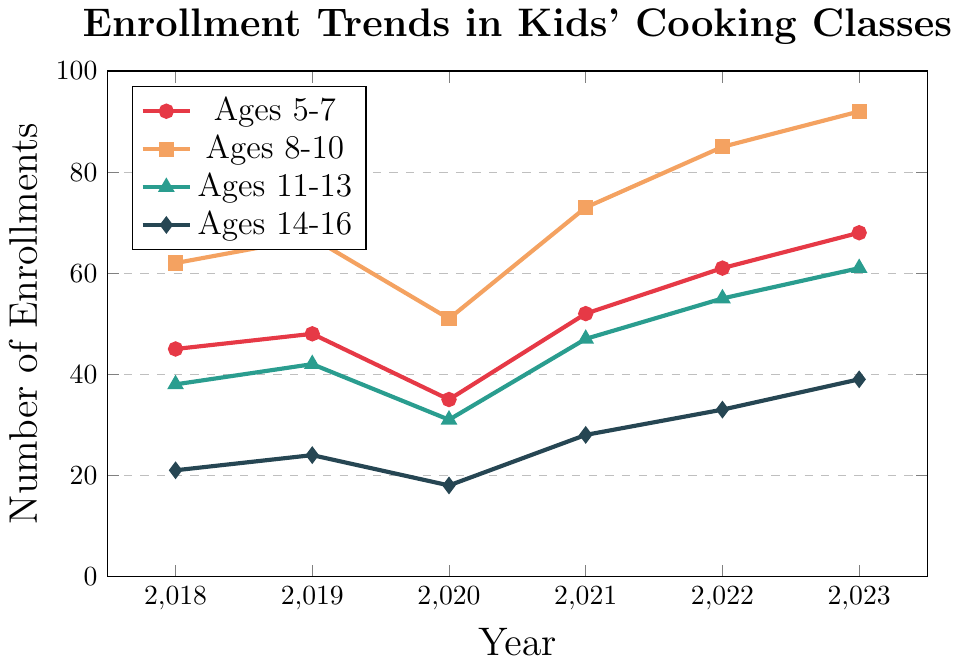What was the enrollment for Ages 8-10 in 2020? Looking at the plot, locate the line representing Ages 8-10, and find the data point corresponding to the year 2020.
Answer: 51 Which age group had the highest enrollment in 2023? Identify the highest point on the lines for the year 2023, which represents the enrollment for each age group. The line for Ages 8-10 (92) is the highest.
Answer: Ages 8-10 What is the total enrollment for all age groups in 2021? Sum the data points for all age groups. For 2021: Ages 5-7 (52) + Ages 8-10 (73) + Ages 11-13 (47) + Ages 14-16 (28). Total = 52 + 73 + 47 + 28 = 200
Answer: 200 How does the enrollment trend for Ages 5-7 from 2018 to 2023 appear? Follow the line representing Ages 5-7 from 2018 (45) to 2023 (68). It shows a general upward trend with a dip in 2020.
Answer: Generally upward Which year saw the lowest enrollment for Ages 11-13? Locate the lowest point on the line representing Ages 11-13. The lowest enrollment was 31 in 2020.
Answer: 2020 By how much did the enrollment for Ages 14-16 increase from 2018 to 2023? Find the enrollment numbers for Ages 14-16 in 2018 (21) and in 2023 (39). The increase is 39 - 21 = 18.
Answer: 18 Which age group experienced the largest increase in enrollments between 2018 and 2023? Calculate the increase for each age group:
  Ages 5-7: 68 - 45 = 23
  Ages 8-10: 92 - 62 = 30
  Ages 11-13: 61 - 38 = 23
  Ages 14-16: 39 - 21 = 18
The largest increase is for Ages 8-10 (30).
Answer: Ages 8-10 What is the average enrollment for Ages 14-16 over the period 2018-2023? Sum the enrollment for Ages 14-16 across all years and divide by the number of years.
  (21 + 24 + 18 + 28 + 33 + 39) / 6 = 163 / 6 = 27.17
Answer: 27.17 In which year did all age groups see an increase in enrollments compared to the previous year? Compare each year to the previous one for all age groups. In 2021, all age groups had higher enrollments than in 2020.
Answer: 2021 